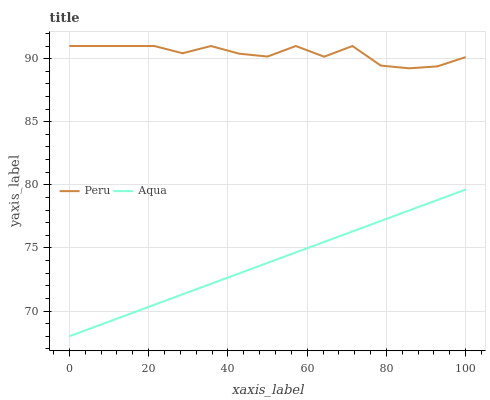Does Aqua have the minimum area under the curve?
Answer yes or no. Yes. Does Peru have the maximum area under the curve?
Answer yes or no. Yes. Does Peru have the minimum area under the curve?
Answer yes or no. No. Is Aqua the smoothest?
Answer yes or no. Yes. Is Peru the roughest?
Answer yes or no. Yes. Is Peru the smoothest?
Answer yes or no. No. Does Aqua have the lowest value?
Answer yes or no. Yes. Does Peru have the lowest value?
Answer yes or no. No. Does Peru have the highest value?
Answer yes or no. Yes. Is Aqua less than Peru?
Answer yes or no. Yes. Is Peru greater than Aqua?
Answer yes or no. Yes. Does Aqua intersect Peru?
Answer yes or no. No. 